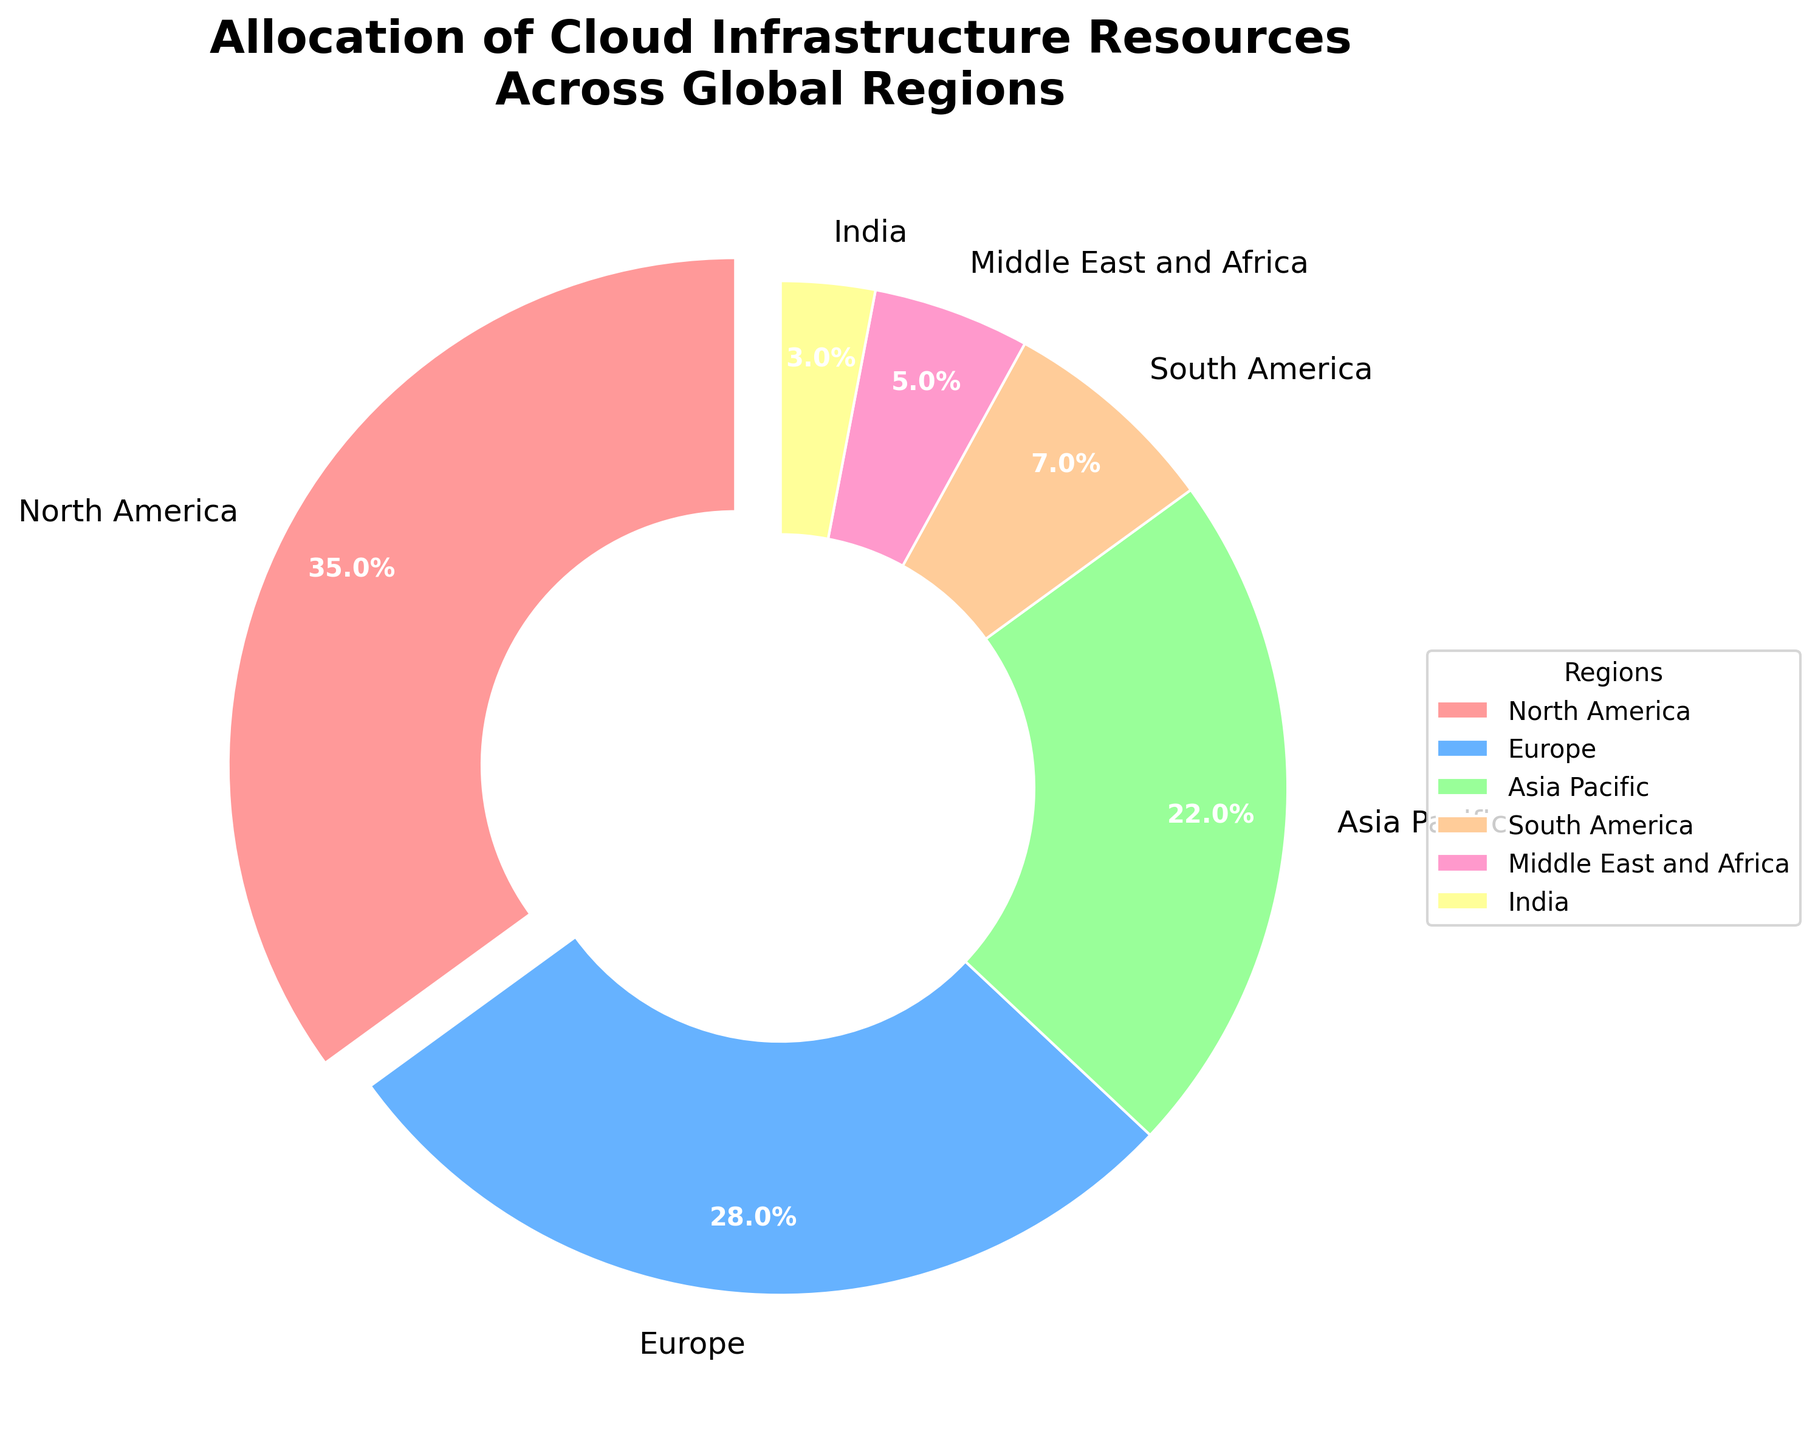What's the most allocated region for cloud infrastructure resources? The pie chart shows that North America has the largest slice and is labeled with 35%, indicating it's the region with the highest allocation.
Answer: North America Which region has the least allocation of cloud infrastructure resources? The chart slice labeled with 3% is the smallest and corresponds to India, indicating it has the least allocation.
Answer: India Which two regions combined have approximately half of the total allocation? North America has 35% and Europe has 28%, combining these percentages gives 35% + 28% = 63%, which is more than half. The two next closest are North America and Asia Pacific: 35% + 22% = 57%.
Answer: North America and Europe How does the allocation of Europe compare to Asia Pacific? Europe has 28% allocation, whereas Asia Pacific has 22%. Since 28% is more than 22%, Europe has a higher allocation than Asia Pacific.
Answer: Europe has more What is the combined allocation percentage for South America, Middle East and Africa, and India? Sum the values for these regions: South America (7%) + Middle East and Africa (5%) + India (3%) = 7% + 5% + 3% = 15%.
Answer: 15% Which color represents the Middle East and Africa region in the pie chart? The Middle East and Africa region is indicated by the slice with 5% and is the fifth listed region. The color corresponding to this slice is yellow.
Answer: Yellow How much greater is North America's allocation compared to South America's? North America has 35% and South America has 7%. The difference is 35% - 7% = 28%.
Answer: 28% What percentage of the allocation is covered by regions outside North America, Europe, and Asia Pacific? Sum the allocations for South America (7%), Middle East and Africa (5%), and India (3%): 7% + 5% + 3% = 15%.
Answer: 15% Which region is allocated more resources: Europe or all regions in the Southern Hemisphere combined? The regions in the Southern Hemisphere include South America (7%) and Middle East and Africa (5%), totaling 7% + 5% = 12%. Europe has 28%, which is greater.
Answer: Europe 